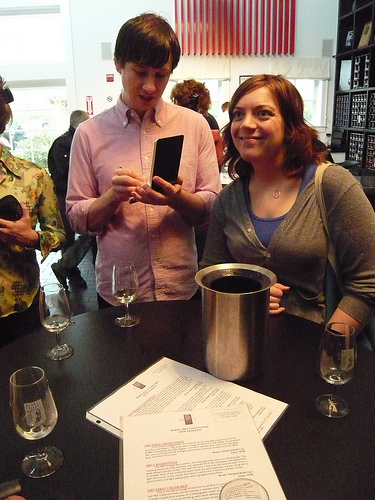<image>
Can you confirm if the man is in front of the woman? No. The man is not in front of the woman. The spatial positioning shows a different relationship between these objects. 